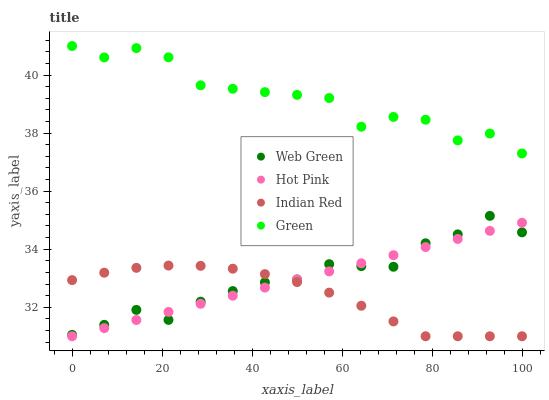Does Indian Red have the minimum area under the curve?
Answer yes or no. Yes. Does Green have the maximum area under the curve?
Answer yes or no. Yes. Does Green have the minimum area under the curve?
Answer yes or no. No. Does Indian Red have the maximum area under the curve?
Answer yes or no. No. Is Hot Pink the smoothest?
Answer yes or no. Yes. Is Green the roughest?
Answer yes or no. Yes. Is Indian Red the smoothest?
Answer yes or no. No. Is Indian Red the roughest?
Answer yes or no. No. Does Hot Pink have the lowest value?
Answer yes or no. Yes. Does Green have the lowest value?
Answer yes or no. No. Does Green have the highest value?
Answer yes or no. Yes. Does Indian Red have the highest value?
Answer yes or no. No. Is Hot Pink less than Green?
Answer yes or no. Yes. Is Green greater than Web Green?
Answer yes or no. Yes. Does Hot Pink intersect Web Green?
Answer yes or no. Yes. Is Hot Pink less than Web Green?
Answer yes or no. No. Is Hot Pink greater than Web Green?
Answer yes or no. No. Does Hot Pink intersect Green?
Answer yes or no. No. 